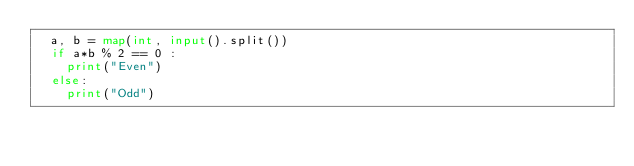<code> <loc_0><loc_0><loc_500><loc_500><_Python_>  a, b = map(int, input().split())
  if a*b % 2 == 0 :
    print("Even")
  else:
    print("Odd")
</code> 